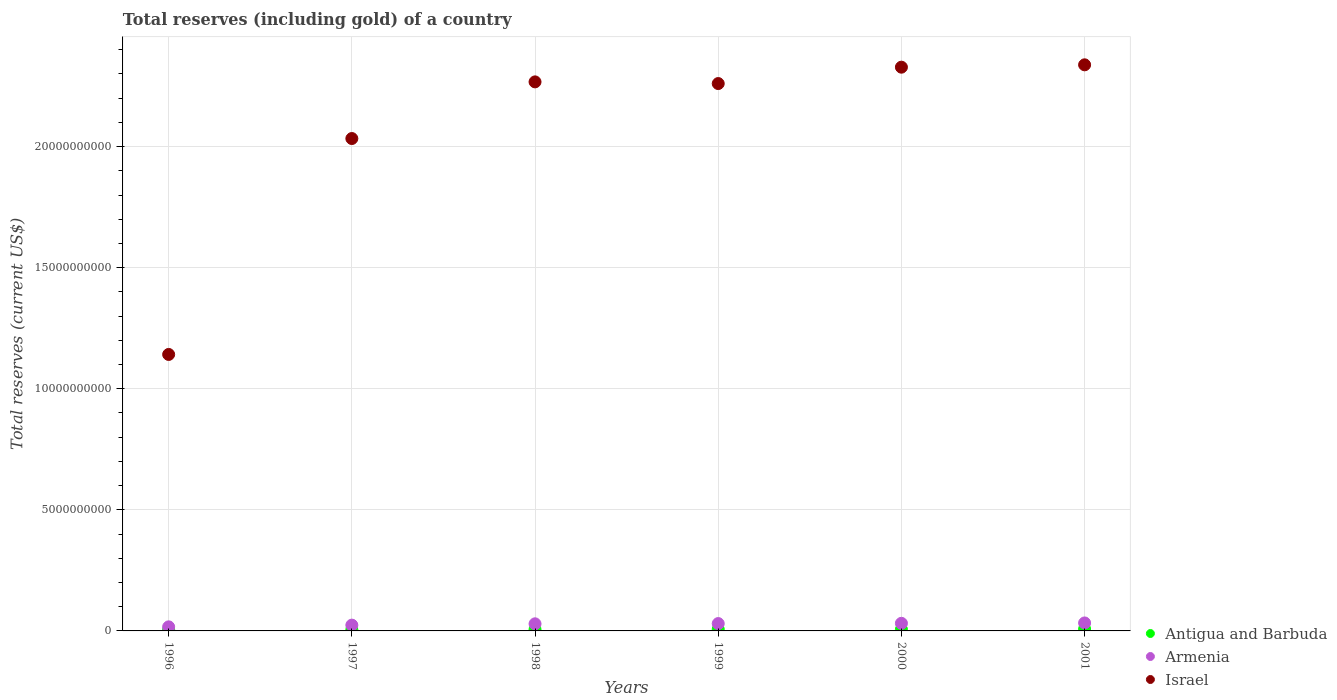How many different coloured dotlines are there?
Offer a very short reply. 3. Is the number of dotlines equal to the number of legend labels?
Offer a very short reply. Yes. What is the total reserves (including gold) in Armenia in 1997?
Ensure brevity in your answer.  2.39e+08. Across all years, what is the maximum total reserves (including gold) in Armenia?
Offer a very short reply. 3.30e+08. Across all years, what is the minimum total reserves (including gold) in Armenia?
Your answer should be compact. 1.68e+08. In which year was the total reserves (including gold) in Israel minimum?
Keep it short and to the point. 1996. What is the total total reserves (including gold) in Antigua and Barbuda in the graph?
Provide a short and direct response. 3.71e+08. What is the difference between the total reserves (including gold) in Israel in 1997 and that in 2001?
Keep it short and to the point. -3.04e+09. What is the difference between the total reserves (including gold) in Armenia in 1998 and the total reserves (including gold) in Antigua and Barbuda in 1996?
Make the answer very short. 2.45e+08. What is the average total reserves (including gold) in Antigua and Barbuda per year?
Your answer should be compact. 6.18e+07. In the year 1996, what is the difference between the total reserves (including gold) in Armenia and total reserves (including gold) in Israel?
Your answer should be compact. -1.12e+1. In how many years, is the total reserves (including gold) in Antigua and Barbuda greater than 1000000000 US$?
Provide a succinct answer. 0. What is the ratio of the total reserves (including gold) in Armenia in 1998 to that in 2001?
Ensure brevity in your answer.  0.89. Is the total reserves (including gold) in Armenia in 1999 less than that in 2001?
Your answer should be compact. Yes. What is the difference between the highest and the second highest total reserves (including gold) in Israel?
Your answer should be compact. 9.74e+07. What is the difference between the highest and the lowest total reserves (including gold) in Antigua and Barbuda?
Your answer should be very brief. 3.20e+07. In how many years, is the total reserves (including gold) in Antigua and Barbuda greater than the average total reserves (including gold) in Antigua and Barbuda taken over all years?
Give a very brief answer. 3. Is it the case that in every year, the sum of the total reserves (including gold) in Armenia and total reserves (including gold) in Israel  is greater than the total reserves (including gold) in Antigua and Barbuda?
Give a very brief answer. Yes. Does the total reserves (including gold) in Antigua and Barbuda monotonically increase over the years?
Provide a short and direct response. No. Is the total reserves (including gold) in Armenia strictly greater than the total reserves (including gold) in Antigua and Barbuda over the years?
Ensure brevity in your answer.  Yes. Is the total reserves (including gold) in Israel strictly less than the total reserves (including gold) in Armenia over the years?
Give a very brief answer. No. How many years are there in the graph?
Provide a short and direct response. 6. What is the difference between two consecutive major ticks on the Y-axis?
Ensure brevity in your answer.  5.00e+09. Are the values on the major ticks of Y-axis written in scientific E-notation?
Your answer should be compact. No. Does the graph contain grids?
Keep it short and to the point. Yes. Where does the legend appear in the graph?
Your response must be concise. Bottom right. How many legend labels are there?
Your response must be concise. 3. How are the legend labels stacked?
Ensure brevity in your answer.  Vertical. What is the title of the graph?
Offer a terse response. Total reserves (including gold) of a country. What is the label or title of the Y-axis?
Provide a succinct answer. Total reserves (current US$). What is the Total reserves (current US$) of Antigua and Barbuda in 1996?
Your answer should be compact. 4.77e+07. What is the Total reserves (current US$) of Armenia in 1996?
Provide a short and direct response. 1.68e+08. What is the Total reserves (current US$) of Israel in 1996?
Your response must be concise. 1.14e+1. What is the Total reserves (current US$) of Antigua and Barbuda in 1997?
Provide a short and direct response. 5.07e+07. What is the Total reserves (current US$) in Armenia in 1997?
Offer a very short reply. 2.39e+08. What is the Total reserves (current US$) of Israel in 1997?
Offer a terse response. 2.03e+1. What is the Total reserves (current US$) of Antigua and Barbuda in 1998?
Give a very brief answer. 5.94e+07. What is the Total reserves (current US$) in Armenia in 1998?
Provide a short and direct response. 2.93e+08. What is the Total reserves (current US$) of Israel in 1998?
Your answer should be very brief. 2.27e+1. What is the Total reserves (current US$) in Antigua and Barbuda in 1999?
Your response must be concise. 6.97e+07. What is the Total reserves (current US$) in Armenia in 1999?
Your answer should be very brief. 3.04e+08. What is the Total reserves (current US$) in Israel in 1999?
Keep it short and to the point. 2.26e+1. What is the Total reserves (current US$) of Antigua and Barbuda in 2000?
Your response must be concise. 6.36e+07. What is the Total reserves (current US$) of Armenia in 2000?
Your answer should be very brief. 3.14e+08. What is the Total reserves (current US$) in Israel in 2000?
Make the answer very short. 2.33e+1. What is the Total reserves (current US$) in Antigua and Barbuda in 2001?
Your answer should be compact. 7.97e+07. What is the Total reserves (current US$) of Armenia in 2001?
Your response must be concise. 3.30e+08. What is the Total reserves (current US$) of Israel in 2001?
Provide a short and direct response. 2.34e+1. Across all years, what is the maximum Total reserves (current US$) in Antigua and Barbuda?
Offer a terse response. 7.97e+07. Across all years, what is the maximum Total reserves (current US$) of Armenia?
Offer a terse response. 3.30e+08. Across all years, what is the maximum Total reserves (current US$) in Israel?
Provide a succinct answer. 2.34e+1. Across all years, what is the minimum Total reserves (current US$) in Antigua and Barbuda?
Offer a very short reply. 4.77e+07. Across all years, what is the minimum Total reserves (current US$) in Armenia?
Make the answer very short. 1.68e+08. Across all years, what is the minimum Total reserves (current US$) in Israel?
Give a very brief answer. 1.14e+1. What is the total Total reserves (current US$) of Antigua and Barbuda in the graph?
Your answer should be very brief. 3.71e+08. What is the total Total reserves (current US$) of Armenia in the graph?
Provide a succinct answer. 1.65e+09. What is the total Total reserves (current US$) of Israel in the graph?
Your answer should be compact. 1.24e+11. What is the difference between the Total reserves (current US$) in Antigua and Barbuda in 1996 and that in 1997?
Ensure brevity in your answer.  -2.96e+06. What is the difference between the Total reserves (current US$) in Armenia in 1996 and that in 1997?
Keep it short and to the point. -7.10e+07. What is the difference between the Total reserves (current US$) of Israel in 1996 and that in 1997?
Your response must be concise. -8.92e+09. What is the difference between the Total reserves (current US$) of Antigua and Barbuda in 1996 and that in 1998?
Make the answer very short. -1.16e+07. What is the difference between the Total reserves (current US$) in Armenia in 1996 and that in 1998?
Ensure brevity in your answer.  -1.25e+08. What is the difference between the Total reserves (current US$) of Israel in 1996 and that in 1998?
Your answer should be compact. -1.13e+1. What is the difference between the Total reserves (current US$) of Antigua and Barbuda in 1996 and that in 1999?
Keep it short and to the point. -2.20e+07. What is the difference between the Total reserves (current US$) of Armenia in 1996 and that in 1999?
Keep it short and to the point. -1.35e+08. What is the difference between the Total reserves (current US$) in Israel in 1996 and that in 1999?
Your response must be concise. -1.12e+1. What is the difference between the Total reserves (current US$) of Antigua and Barbuda in 1996 and that in 2000?
Keep it short and to the point. -1.58e+07. What is the difference between the Total reserves (current US$) of Armenia in 1996 and that in 2000?
Ensure brevity in your answer.  -1.46e+08. What is the difference between the Total reserves (current US$) in Israel in 1996 and that in 2000?
Offer a terse response. -1.19e+1. What is the difference between the Total reserves (current US$) in Antigua and Barbuda in 1996 and that in 2001?
Provide a succinct answer. -3.20e+07. What is the difference between the Total reserves (current US$) in Armenia in 1996 and that in 2001?
Your answer should be very brief. -1.61e+08. What is the difference between the Total reserves (current US$) in Israel in 1996 and that in 2001?
Ensure brevity in your answer.  -1.20e+1. What is the difference between the Total reserves (current US$) in Antigua and Barbuda in 1997 and that in 1998?
Provide a succinct answer. -8.67e+06. What is the difference between the Total reserves (current US$) of Armenia in 1997 and that in 1998?
Provide a short and direct response. -5.39e+07. What is the difference between the Total reserves (current US$) of Israel in 1997 and that in 1998?
Offer a terse response. -2.34e+09. What is the difference between the Total reserves (current US$) of Antigua and Barbuda in 1997 and that in 1999?
Your response must be concise. -1.90e+07. What is the difference between the Total reserves (current US$) of Armenia in 1997 and that in 1999?
Give a very brief answer. -6.43e+07. What is the difference between the Total reserves (current US$) of Israel in 1997 and that in 1999?
Provide a succinct answer. -2.27e+09. What is the difference between the Total reserves (current US$) in Antigua and Barbuda in 1997 and that in 2000?
Provide a short and direct response. -1.29e+07. What is the difference between the Total reserves (current US$) in Armenia in 1997 and that in 2000?
Offer a very short reply. -7.50e+07. What is the difference between the Total reserves (current US$) of Israel in 1997 and that in 2000?
Provide a succinct answer. -2.95e+09. What is the difference between the Total reserves (current US$) of Antigua and Barbuda in 1997 and that in 2001?
Offer a very short reply. -2.90e+07. What is the difference between the Total reserves (current US$) of Armenia in 1997 and that in 2001?
Make the answer very short. -9.04e+07. What is the difference between the Total reserves (current US$) in Israel in 1997 and that in 2001?
Your answer should be very brief. -3.04e+09. What is the difference between the Total reserves (current US$) of Antigua and Barbuda in 1998 and that in 1999?
Provide a succinct answer. -1.04e+07. What is the difference between the Total reserves (current US$) of Armenia in 1998 and that in 1999?
Offer a very short reply. -1.03e+07. What is the difference between the Total reserves (current US$) of Israel in 1998 and that in 1999?
Ensure brevity in your answer.  6.94e+07. What is the difference between the Total reserves (current US$) of Antigua and Barbuda in 1998 and that in 2000?
Provide a succinct answer. -4.19e+06. What is the difference between the Total reserves (current US$) of Armenia in 1998 and that in 2000?
Ensure brevity in your answer.  -2.10e+07. What is the difference between the Total reserves (current US$) of Israel in 1998 and that in 2000?
Offer a very short reply. -6.07e+08. What is the difference between the Total reserves (current US$) of Antigua and Barbuda in 1998 and that in 2001?
Ensure brevity in your answer.  -2.04e+07. What is the difference between the Total reserves (current US$) of Armenia in 1998 and that in 2001?
Your answer should be very brief. -3.65e+07. What is the difference between the Total reserves (current US$) of Israel in 1998 and that in 2001?
Ensure brevity in your answer.  -7.04e+08. What is the difference between the Total reserves (current US$) in Antigua and Barbuda in 1999 and that in 2000?
Keep it short and to the point. 6.17e+06. What is the difference between the Total reserves (current US$) of Armenia in 1999 and that in 2000?
Offer a very short reply. -1.07e+07. What is the difference between the Total reserves (current US$) in Israel in 1999 and that in 2000?
Offer a very short reply. -6.76e+08. What is the difference between the Total reserves (current US$) in Antigua and Barbuda in 1999 and that in 2001?
Offer a terse response. -9.99e+06. What is the difference between the Total reserves (current US$) of Armenia in 1999 and that in 2001?
Offer a very short reply. -2.61e+07. What is the difference between the Total reserves (current US$) of Israel in 1999 and that in 2001?
Ensure brevity in your answer.  -7.74e+08. What is the difference between the Total reserves (current US$) in Antigua and Barbuda in 2000 and that in 2001?
Ensure brevity in your answer.  -1.62e+07. What is the difference between the Total reserves (current US$) of Armenia in 2000 and that in 2001?
Make the answer very short. -1.54e+07. What is the difference between the Total reserves (current US$) of Israel in 2000 and that in 2001?
Your response must be concise. -9.74e+07. What is the difference between the Total reserves (current US$) of Antigua and Barbuda in 1996 and the Total reserves (current US$) of Armenia in 1997?
Keep it short and to the point. -1.91e+08. What is the difference between the Total reserves (current US$) of Antigua and Barbuda in 1996 and the Total reserves (current US$) of Israel in 1997?
Offer a very short reply. -2.03e+1. What is the difference between the Total reserves (current US$) of Armenia in 1996 and the Total reserves (current US$) of Israel in 1997?
Ensure brevity in your answer.  -2.02e+1. What is the difference between the Total reserves (current US$) in Antigua and Barbuda in 1996 and the Total reserves (current US$) in Armenia in 1998?
Ensure brevity in your answer.  -2.45e+08. What is the difference between the Total reserves (current US$) of Antigua and Barbuda in 1996 and the Total reserves (current US$) of Israel in 1998?
Give a very brief answer. -2.26e+1. What is the difference between the Total reserves (current US$) in Armenia in 1996 and the Total reserves (current US$) in Israel in 1998?
Provide a succinct answer. -2.25e+1. What is the difference between the Total reserves (current US$) of Antigua and Barbuda in 1996 and the Total reserves (current US$) of Armenia in 1999?
Make the answer very short. -2.56e+08. What is the difference between the Total reserves (current US$) of Antigua and Barbuda in 1996 and the Total reserves (current US$) of Israel in 1999?
Ensure brevity in your answer.  -2.26e+1. What is the difference between the Total reserves (current US$) in Armenia in 1996 and the Total reserves (current US$) in Israel in 1999?
Make the answer very short. -2.24e+1. What is the difference between the Total reserves (current US$) in Antigua and Barbuda in 1996 and the Total reserves (current US$) in Armenia in 2000?
Provide a succinct answer. -2.66e+08. What is the difference between the Total reserves (current US$) in Antigua and Barbuda in 1996 and the Total reserves (current US$) in Israel in 2000?
Provide a succinct answer. -2.32e+1. What is the difference between the Total reserves (current US$) of Armenia in 1996 and the Total reserves (current US$) of Israel in 2000?
Give a very brief answer. -2.31e+1. What is the difference between the Total reserves (current US$) in Antigua and Barbuda in 1996 and the Total reserves (current US$) in Armenia in 2001?
Ensure brevity in your answer.  -2.82e+08. What is the difference between the Total reserves (current US$) in Antigua and Barbuda in 1996 and the Total reserves (current US$) in Israel in 2001?
Offer a terse response. -2.33e+1. What is the difference between the Total reserves (current US$) of Armenia in 1996 and the Total reserves (current US$) of Israel in 2001?
Keep it short and to the point. -2.32e+1. What is the difference between the Total reserves (current US$) in Antigua and Barbuda in 1997 and the Total reserves (current US$) in Armenia in 1998?
Give a very brief answer. -2.42e+08. What is the difference between the Total reserves (current US$) in Antigua and Barbuda in 1997 and the Total reserves (current US$) in Israel in 1998?
Offer a very short reply. -2.26e+1. What is the difference between the Total reserves (current US$) of Armenia in 1997 and the Total reserves (current US$) of Israel in 1998?
Ensure brevity in your answer.  -2.24e+1. What is the difference between the Total reserves (current US$) of Antigua and Barbuda in 1997 and the Total reserves (current US$) of Armenia in 1999?
Offer a very short reply. -2.53e+08. What is the difference between the Total reserves (current US$) in Antigua and Barbuda in 1997 and the Total reserves (current US$) in Israel in 1999?
Ensure brevity in your answer.  -2.26e+1. What is the difference between the Total reserves (current US$) in Armenia in 1997 and the Total reserves (current US$) in Israel in 1999?
Give a very brief answer. -2.24e+1. What is the difference between the Total reserves (current US$) of Antigua and Barbuda in 1997 and the Total reserves (current US$) of Armenia in 2000?
Offer a very short reply. -2.64e+08. What is the difference between the Total reserves (current US$) in Antigua and Barbuda in 1997 and the Total reserves (current US$) in Israel in 2000?
Keep it short and to the point. -2.32e+1. What is the difference between the Total reserves (current US$) in Armenia in 1997 and the Total reserves (current US$) in Israel in 2000?
Your response must be concise. -2.30e+1. What is the difference between the Total reserves (current US$) in Antigua and Barbuda in 1997 and the Total reserves (current US$) in Armenia in 2001?
Provide a succinct answer. -2.79e+08. What is the difference between the Total reserves (current US$) in Antigua and Barbuda in 1997 and the Total reserves (current US$) in Israel in 2001?
Provide a succinct answer. -2.33e+1. What is the difference between the Total reserves (current US$) of Armenia in 1997 and the Total reserves (current US$) of Israel in 2001?
Offer a very short reply. -2.31e+1. What is the difference between the Total reserves (current US$) in Antigua and Barbuda in 1998 and the Total reserves (current US$) in Armenia in 1999?
Keep it short and to the point. -2.44e+08. What is the difference between the Total reserves (current US$) in Antigua and Barbuda in 1998 and the Total reserves (current US$) in Israel in 1999?
Your answer should be compact. -2.25e+1. What is the difference between the Total reserves (current US$) of Armenia in 1998 and the Total reserves (current US$) of Israel in 1999?
Your response must be concise. -2.23e+1. What is the difference between the Total reserves (current US$) of Antigua and Barbuda in 1998 and the Total reserves (current US$) of Armenia in 2000?
Offer a terse response. -2.55e+08. What is the difference between the Total reserves (current US$) in Antigua and Barbuda in 1998 and the Total reserves (current US$) in Israel in 2000?
Your answer should be compact. -2.32e+1. What is the difference between the Total reserves (current US$) in Armenia in 1998 and the Total reserves (current US$) in Israel in 2000?
Keep it short and to the point. -2.30e+1. What is the difference between the Total reserves (current US$) of Antigua and Barbuda in 1998 and the Total reserves (current US$) of Armenia in 2001?
Offer a very short reply. -2.70e+08. What is the difference between the Total reserves (current US$) in Antigua and Barbuda in 1998 and the Total reserves (current US$) in Israel in 2001?
Offer a very short reply. -2.33e+1. What is the difference between the Total reserves (current US$) in Armenia in 1998 and the Total reserves (current US$) in Israel in 2001?
Offer a terse response. -2.31e+1. What is the difference between the Total reserves (current US$) in Antigua and Barbuda in 1999 and the Total reserves (current US$) in Armenia in 2000?
Keep it short and to the point. -2.44e+08. What is the difference between the Total reserves (current US$) in Antigua and Barbuda in 1999 and the Total reserves (current US$) in Israel in 2000?
Keep it short and to the point. -2.32e+1. What is the difference between the Total reserves (current US$) in Armenia in 1999 and the Total reserves (current US$) in Israel in 2000?
Your answer should be very brief. -2.30e+1. What is the difference between the Total reserves (current US$) in Antigua and Barbuda in 1999 and the Total reserves (current US$) in Armenia in 2001?
Provide a short and direct response. -2.60e+08. What is the difference between the Total reserves (current US$) in Antigua and Barbuda in 1999 and the Total reserves (current US$) in Israel in 2001?
Your answer should be very brief. -2.33e+1. What is the difference between the Total reserves (current US$) of Armenia in 1999 and the Total reserves (current US$) of Israel in 2001?
Your response must be concise. -2.31e+1. What is the difference between the Total reserves (current US$) of Antigua and Barbuda in 2000 and the Total reserves (current US$) of Armenia in 2001?
Provide a short and direct response. -2.66e+08. What is the difference between the Total reserves (current US$) in Antigua and Barbuda in 2000 and the Total reserves (current US$) in Israel in 2001?
Give a very brief answer. -2.33e+1. What is the difference between the Total reserves (current US$) of Armenia in 2000 and the Total reserves (current US$) of Israel in 2001?
Ensure brevity in your answer.  -2.31e+1. What is the average Total reserves (current US$) in Antigua and Barbuda per year?
Provide a short and direct response. 6.18e+07. What is the average Total reserves (current US$) of Armenia per year?
Provide a succinct answer. 2.75e+08. What is the average Total reserves (current US$) of Israel per year?
Provide a succinct answer. 2.06e+1. In the year 1996, what is the difference between the Total reserves (current US$) of Antigua and Barbuda and Total reserves (current US$) of Armenia?
Your response must be concise. -1.20e+08. In the year 1996, what is the difference between the Total reserves (current US$) in Antigua and Barbuda and Total reserves (current US$) in Israel?
Make the answer very short. -1.14e+1. In the year 1996, what is the difference between the Total reserves (current US$) of Armenia and Total reserves (current US$) of Israel?
Your answer should be very brief. -1.12e+1. In the year 1997, what is the difference between the Total reserves (current US$) in Antigua and Barbuda and Total reserves (current US$) in Armenia?
Ensure brevity in your answer.  -1.89e+08. In the year 1997, what is the difference between the Total reserves (current US$) of Antigua and Barbuda and Total reserves (current US$) of Israel?
Make the answer very short. -2.03e+1. In the year 1997, what is the difference between the Total reserves (current US$) of Armenia and Total reserves (current US$) of Israel?
Ensure brevity in your answer.  -2.01e+1. In the year 1998, what is the difference between the Total reserves (current US$) in Antigua and Barbuda and Total reserves (current US$) in Armenia?
Ensure brevity in your answer.  -2.34e+08. In the year 1998, what is the difference between the Total reserves (current US$) in Antigua and Barbuda and Total reserves (current US$) in Israel?
Offer a very short reply. -2.26e+1. In the year 1998, what is the difference between the Total reserves (current US$) in Armenia and Total reserves (current US$) in Israel?
Offer a very short reply. -2.24e+1. In the year 1999, what is the difference between the Total reserves (current US$) of Antigua and Barbuda and Total reserves (current US$) of Armenia?
Ensure brevity in your answer.  -2.34e+08. In the year 1999, what is the difference between the Total reserves (current US$) of Antigua and Barbuda and Total reserves (current US$) of Israel?
Provide a succinct answer. -2.25e+1. In the year 1999, what is the difference between the Total reserves (current US$) in Armenia and Total reserves (current US$) in Israel?
Your answer should be very brief. -2.23e+1. In the year 2000, what is the difference between the Total reserves (current US$) in Antigua and Barbuda and Total reserves (current US$) in Armenia?
Offer a very short reply. -2.51e+08. In the year 2000, what is the difference between the Total reserves (current US$) in Antigua and Barbuda and Total reserves (current US$) in Israel?
Offer a very short reply. -2.32e+1. In the year 2000, what is the difference between the Total reserves (current US$) in Armenia and Total reserves (current US$) in Israel?
Keep it short and to the point. -2.30e+1. In the year 2001, what is the difference between the Total reserves (current US$) in Antigua and Barbuda and Total reserves (current US$) in Armenia?
Your response must be concise. -2.50e+08. In the year 2001, what is the difference between the Total reserves (current US$) in Antigua and Barbuda and Total reserves (current US$) in Israel?
Give a very brief answer. -2.33e+1. In the year 2001, what is the difference between the Total reserves (current US$) of Armenia and Total reserves (current US$) of Israel?
Your response must be concise. -2.30e+1. What is the ratio of the Total reserves (current US$) of Antigua and Barbuda in 1996 to that in 1997?
Offer a terse response. 0.94. What is the ratio of the Total reserves (current US$) in Armenia in 1996 to that in 1997?
Ensure brevity in your answer.  0.7. What is the ratio of the Total reserves (current US$) of Israel in 1996 to that in 1997?
Give a very brief answer. 0.56. What is the ratio of the Total reserves (current US$) of Antigua and Barbuda in 1996 to that in 1998?
Offer a very short reply. 0.8. What is the ratio of the Total reserves (current US$) of Armenia in 1996 to that in 1998?
Keep it short and to the point. 0.57. What is the ratio of the Total reserves (current US$) in Israel in 1996 to that in 1998?
Offer a terse response. 0.5. What is the ratio of the Total reserves (current US$) in Antigua and Barbuda in 1996 to that in 1999?
Make the answer very short. 0.68. What is the ratio of the Total reserves (current US$) of Armenia in 1996 to that in 1999?
Offer a very short reply. 0.55. What is the ratio of the Total reserves (current US$) in Israel in 1996 to that in 1999?
Your response must be concise. 0.51. What is the ratio of the Total reserves (current US$) in Antigua and Barbuda in 1996 to that in 2000?
Offer a very short reply. 0.75. What is the ratio of the Total reserves (current US$) of Armenia in 1996 to that in 2000?
Keep it short and to the point. 0.54. What is the ratio of the Total reserves (current US$) in Israel in 1996 to that in 2000?
Your answer should be very brief. 0.49. What is the ratio of the Total reserves (current US$) of Antigua and Barbuda in 1996 to that in 2001?
Your answer should be compact. 0.6. What is the ratio of the Total reserves (current US$) of Armenia in 1996 to that in 2001?
Provide a short and direct response. 0.51. What is the ratio of the Total reserves (current US$) in Israel in 1996 to that in 2001?
Provide a succinct answer. 0.49. What is the ratio of the Total reserves (current US$) of Antigua and Barbuda in 1997 to that in 1998?
Your answer should be compact. 0.85. What is the ratio of the Total reserves (current US$) of Armenia in 1997 to that in 1998?
Provide a short and direct response. 0.82. What is the ratio of the Total reserves (current US$) of Israel in 1997 to that in 1998?
Keep it short and to the point. 0.9. What is the ratio of the Total reserves (current US$) of Antigua and Barbuda in 1997 to that in 1999?
Your answer should be very brief. 0.73. What is the ratio of the Total reserves (current US$) of Armenia in 1997 to that in 1999?
Your answer should be compact. 0.79. What is the ratio of the Total reserves (current US$) of Israel in 1997 to that in 1999?
Your answer should be very brief. 0.9. What is the ratio of the Total reserves (current US$) of Antigua and Barbuda in 1997 to that in 2000?
Provide a short and direct response. 0.8. What is the ratio of the Total reserves (current US$) in Armenia in 1997 to that in 2000?
Your response must be concise. 0.76. What is the ratio of the Total reserves (current US$) of Israel in 1997 to that in 2000?
Offer a very short reply. 0.87. What is the ratio of the Total reserves (current US$) of Antigua and Barbuda in 1997 to that in 2001?
Provide a short and direct response. 0.64. What is the ratio of the Total reserves (current US$) of Armenia in 1997 to that in 2001?
Your answer should be compact. 0.73. What is the ratio of the Total reserves (current US$) in Israel in 1997 to that in 2001?
Keep it short and to the point. 0.87. What is the ratio of the Total reserves (current US$) of Antigua and Barbuda in 1998 to that in 1999?
Provide a short and direct response. 0.85. What is the ratio of the Total reserves (current US$) in Armenia in 1998 to that in 1999?
Your answer should be compact. 0.97. What is the ratio of the Total reserves (current US$) in Antigua and Barbuda in 1998 to that in 2000?
Provide a short and direct response. 0.93. What is the ratio of the Total reserves (current US$) in Armenia in 1998 to that in 2000?
Your response must be concise. 0.93. What is the ratio of the Total reserves (current US$) of Israel in 1998 to that in 2000?
Give a very brief answer. 0.97. What is the ratio of the Total reserves (current US$) in Antigua and Barbuda in 1998 to that in 2001?
Make the answer very short. 0.74. What is the ratio of the Total reserves (current US$) in Armenia in 1998 to that in 2001?
Make the answer very short. 0.89. What is the ratio of the Total reserves (current US$) of Israel in 1998 to that in 2001?
Ensure brevity in your answer.  0.97. What is the ratio of the Total reserves (current US$) in Antigua and Barbuda in 1999 to that in 2000?
Your answer should be very brief. 1.1. What is the ratio of the Total reserves (current US$) in Israel in 1999 to that in 2000?
Offer a terse response. 0.97. What is the ratio of the Total reserves (current US$) of Antigua and Barbuda in 1999 to that in 2001?
Offer a terse response. 0.87. What is the ratio of the Total reserves (current US$) of Armenia in 1999 to that in 2001?
Provide a short and direct response. 0.92. What is the ratio of the Total reserves (current US$) in Israel in 1999 to that in 2001?
Provide a short and direct response. 0.97. What is the ratio of the Total reserves (current US$) in Antigua and Barbuda in 2000 to that in 2001?
Keep it short and to the point. 0.8. What is the ratio of the Total reserves (current US$) of Armenia in 2000 to that in 2001?
Your answer should be compact. 0.95. What is the ratio of the Total reserves (current US$) in Israel in 2000 to that in 2001?
Make the answer very short. 1. What is the difference between the highest and the second highest Total reserves (current US$) of Antigua and Barbuda?
Offer a very short reply. 9.99e+06. What is the difference between the highest and the second highest Total reserves (current US$) in Armenia?
Offer a very short reply. 1.54e+07. What is the difference between the highest and the second highest Total reserves (current US$) of Israel?
Provide a short and direct response. 9.74e+07. What is the difference between the highest and the lowest Total reserves (current US$) in Antigua and Barbuda?
Provide a short and direct response. 3.20e+07. What is the difference between the highest and the lowest Total reserves (current US$) in Armenia?
Make the answer very short. 1.61e+08. What is the difference between the highest and the lowest Total reserves (current US$) of Israel?
Give a very brief answer. 1.20e+1. 